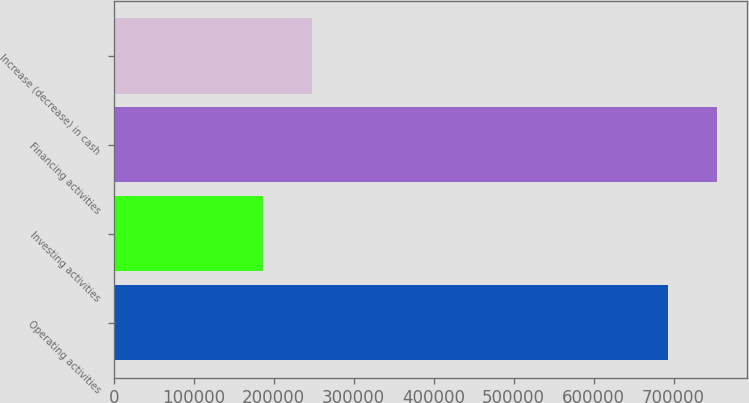Convert chart. <chart><loc_0><loc_0><loc_500><loc_500><bar_chart><fcel>Operating activities<fcel>Investing activities<fcel>Financing activities<fcel>Increase (decrease) in cash<nl><fcel>692679<fcel>186180<fcel>754640<fcel>248141<nl></chart> 